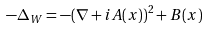<formula> <loc_0><loc_0><loc_500><loc_500>- \Delta _ { W } = - ( \nabla + i A ( x ) ) ^ { 2 } + B ( x )</formula> 